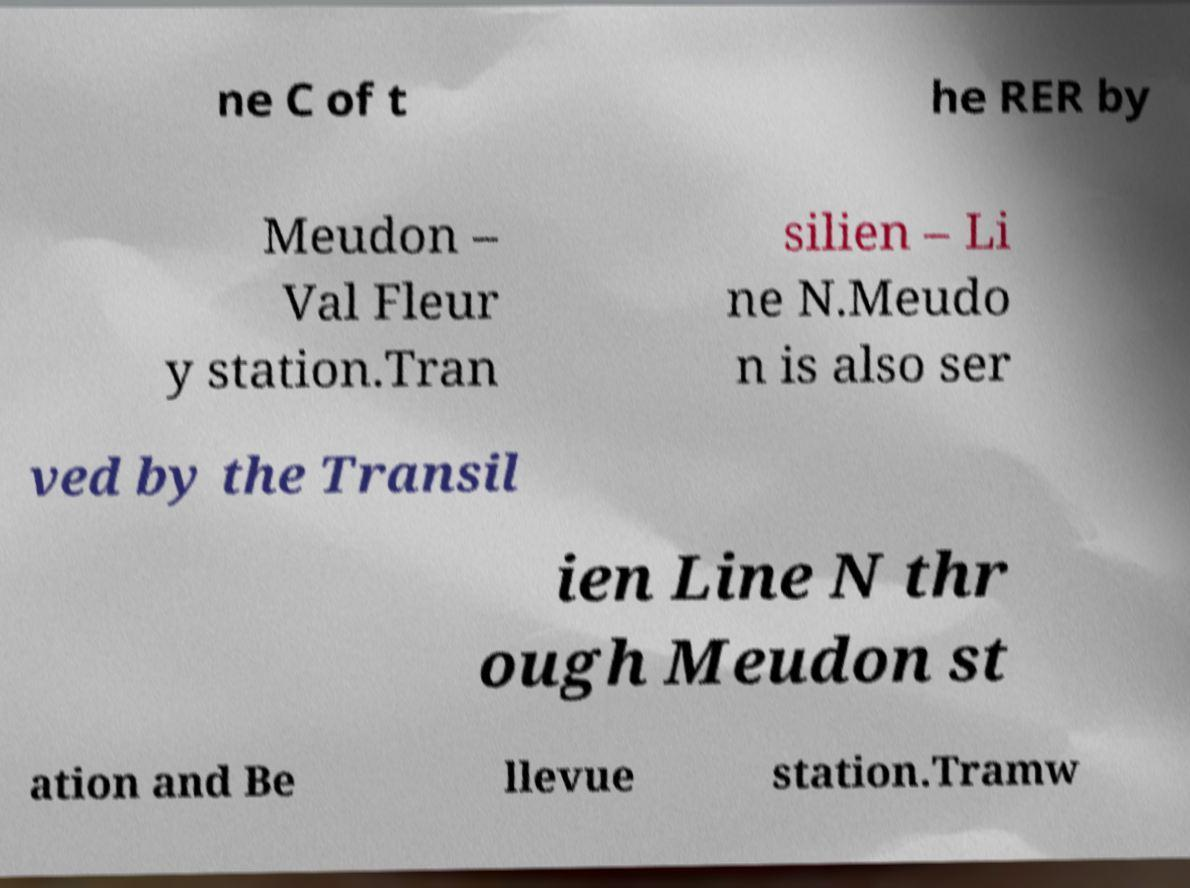What messages or text are displayed in this image? I need them in a readable, typed format. ne C of t he RER by Meudon – Val Fleur y station.Tran silien – Li ne N.Meudo n is also ser ved by the Transil ien Line N thr ough Meudon st ation and Be llevue station.Tramw 